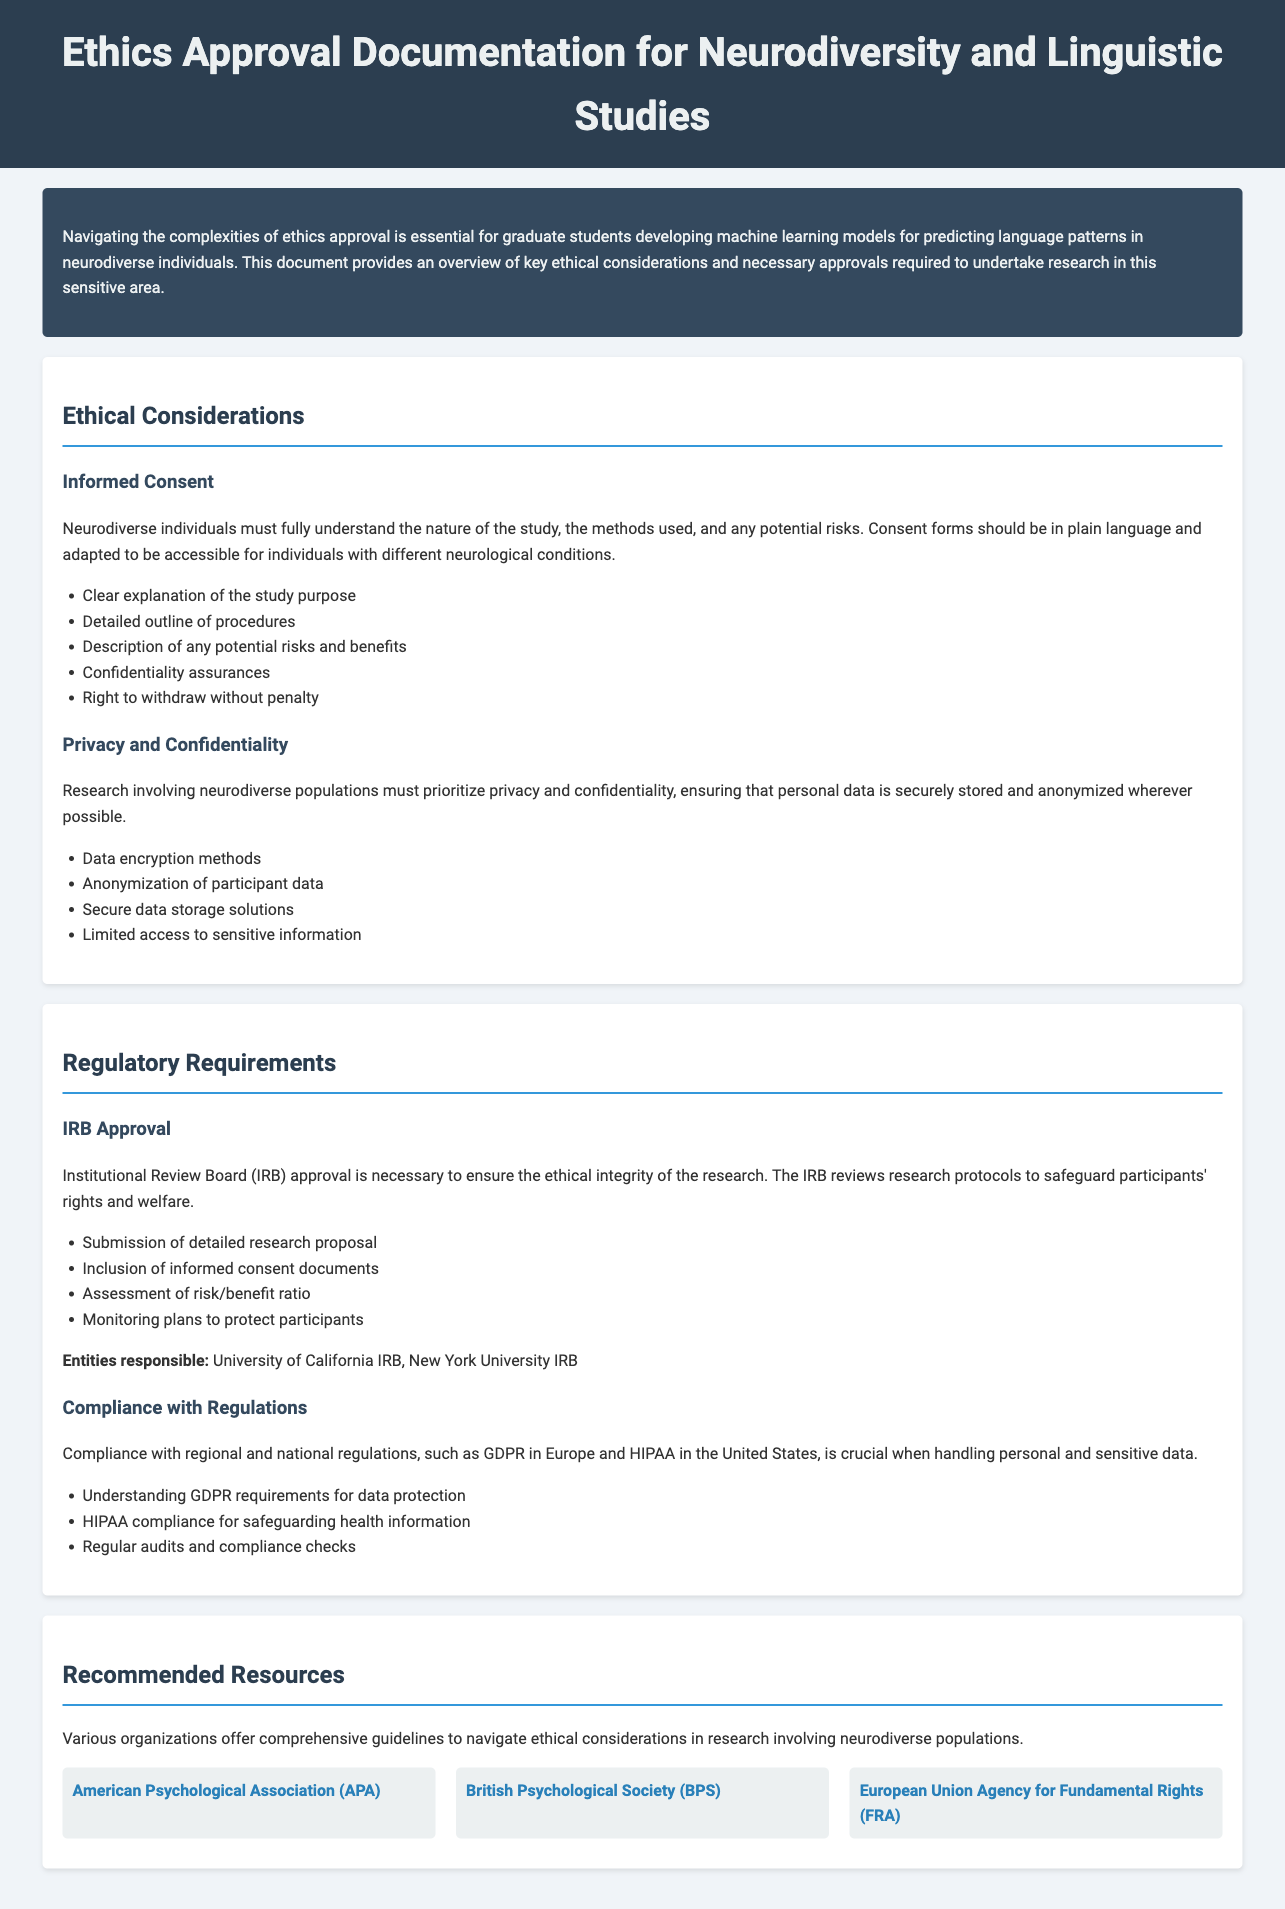what is the title of the document? The title of the document is displayed prominently at the top of the header section.
Answer: Ethics Approval Documentation for Neurodiversity and Linguistic Studies what is the primary focus of the introductory section? The introductory section outlines the importance of ethics approval for graduate students in this research area, emphasizing its complexity.
Answer: Navigating the complexities of ethics approval how many ethical considerations are listed in the document? The document outlines two specific ethical considerations in the section titled Ethical Considerations.
Answer: 2 what does IRB stand for? The acronym IRB is mentioned in the Regulatory Requirements section, specifically in relation to ethics approval.
Answer: Institutional Review Board name one organization that provides guidelines for ethical research. The document lists several organizations in the Recommended Resources section that offer ethical research guidelines.
Answer: American Psychological Association (APA) what is the purpose of the IRB approval? The purpose of IRB approval is detailed in the Regulatory Requirements section regarding safeguarding participant rights.
Answer: Ensure the ethical integrity of the research which regulation is specified for data protection in Europe? The document mentions compliance with specific regulations in the Compliance with Regulations section.
Answer: GDPR what must consent forms be in order to be accessible? The document specifies that consent forms should be converted to a particular format to meet accessibility needs.
Answer: Plain language 